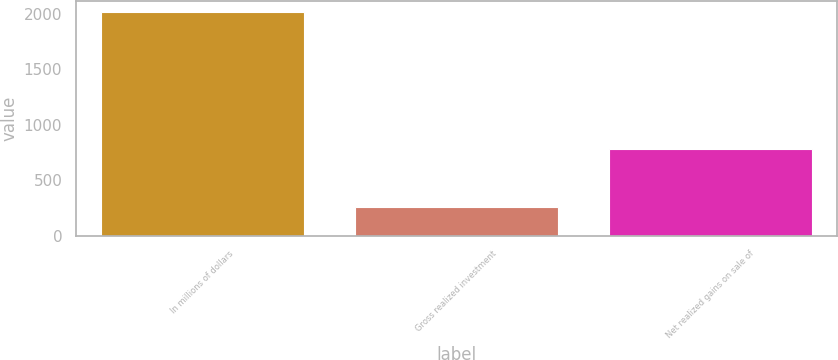Convert chart. <chart><loc_0><loc_0><loc_500><loc_500><bar_chart><fcel>In millions of dollars<fcel>Gross realized investment<fcel>Net realized gains on sale of<nl><fcel>2017<fcel>261<fcel>778<nl></chart> 